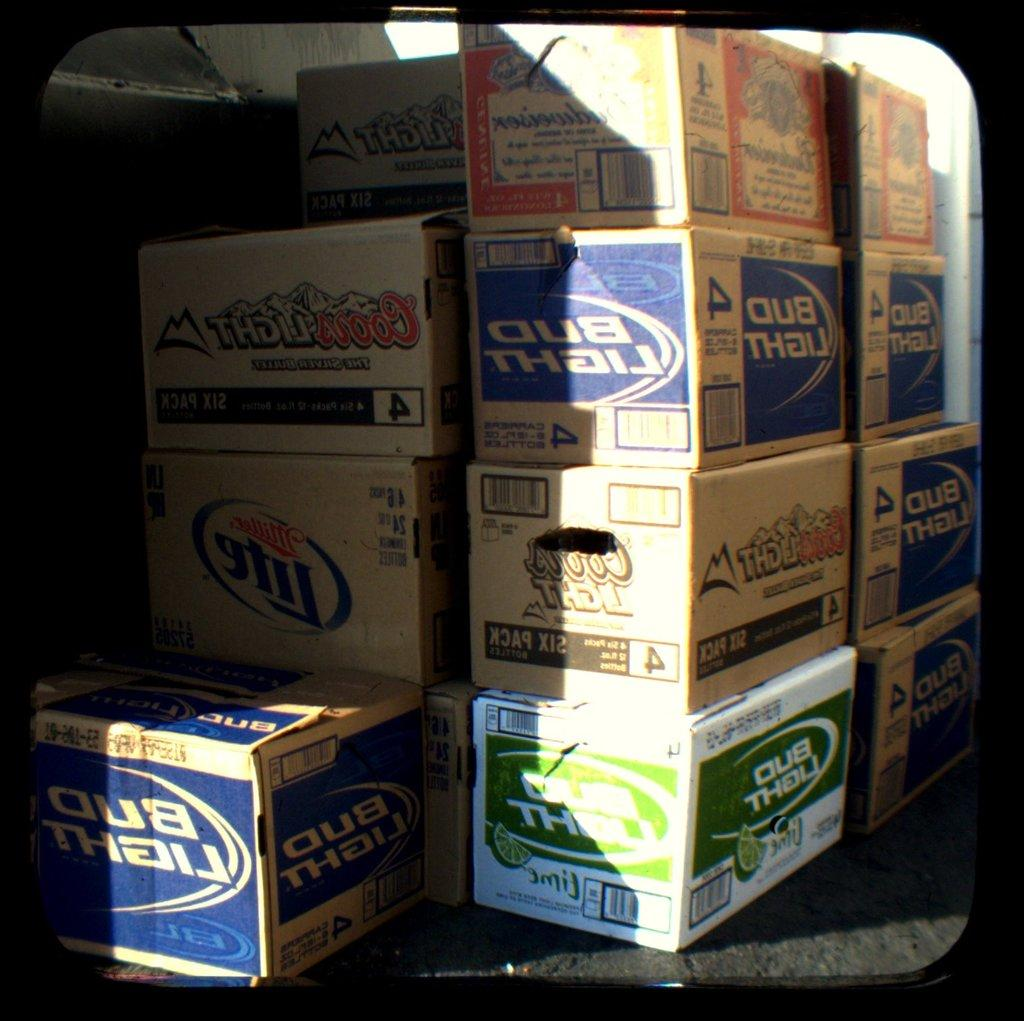What can be seen in the image? There are boxes in the image. What is inside the boxes? The boxes contain items. How are the boxes arranged in the image? The boxes are arranged in an order. What type of carriage is used to transport the boxes in the image? There is no carriage present in the image; the boxes are stationary and not being transported. 